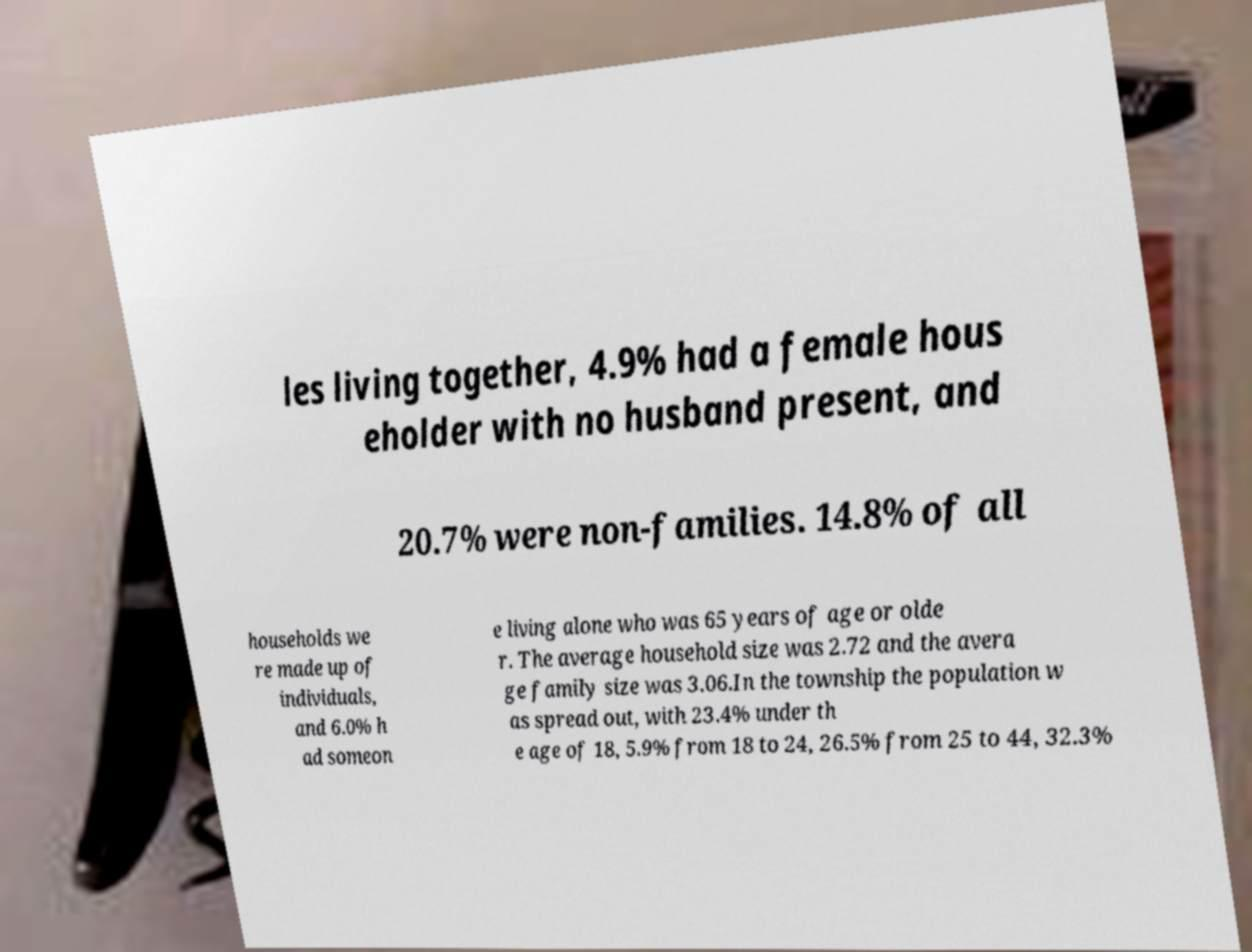Can you accurately transcribe the text from the provided image for me? les living together, 4.9% had a female hous eholder with no husband present, and 20.7% were non-families. 14.8% of all households we re made up of individuals, and 6.0% h ad someon e living alone who was 65 years of age or olde r. The average household size was 2.72 and the avera ge family size was 3.06.In the township the population w as spread out, with 23.4% under th e age of 18, 5.9% from 18 to 24, 26.5% from 25 to 44, 32.3% 